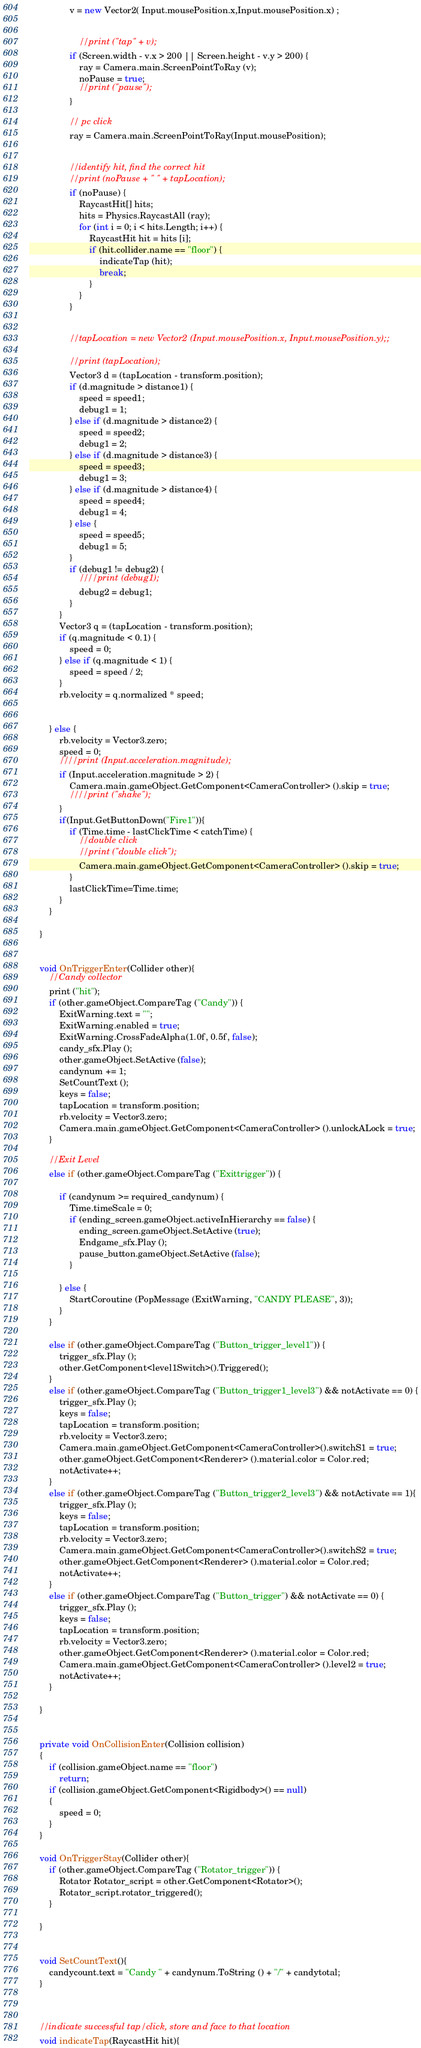<code> <loc_0><loc_0><loc_500><loc_500><_C#_>				v = new Vector2( Input.mousePosition.x,Input.mousePosition.x) ;


					//print ("tap" + v);
				if (Screen.width - v.x > 200 || Screen.height - v.y > 200) {
					ray = Camera.main.ScreenPointToRay (v);
					noPause = true;
					//print ("pause");
				}

				// pc click
				ray = Camera.main.ScreenPointToRay(Input.mousePosition);


				//identify hit, find the correct hit
				//print (noPause + " " + tapLocation);
				if (noPause) {
					RaycastHit[] hits;
					hits = Physics.RaycastAll (ray);
					for (int i = 0; i < hits.Length; i++) {
						RaycastHit hit = hits [i];
						if (hit.collider.name == "floor") {
							indicateTap (hit);
							break;
						}
					}
				}


				//tapLocation = new Vector2 (Input.mousePosition.x, Input.mousePosition.y);;

				//print (tapLocation);
				Vector3 d = (tapLocation - transform.position);
				if (d.magnitude > distance1) {
					speed = speed1;
					debug1 = 1;
				} else if (d.magnitude > distance2) {
					speed = speed2;
					debug1 = 2;
				} else if (d.magnitude > distance3) {
					speed = speed3;
					debug1 = 3;
				} else if (d.magnitude > distance4) {
					speed = speed4;
					debug1 = 4;
				} else {
					speed = speed5;
					debug1 = 5;
				}
				if (debug1 != debug2) {
					////print (debug1);
					debug2 = debug1;
				}
			}
			Vector3 q = (tapLocation - transform.position);
			if (q.magnitude < 0.1) {
				speed = 0;
			} else if (q.magnitude < 1) {
				speed = speed / 2;
			}
			rb.velocity = q.normalized * speed;


		} else {
			rb.velocity = Vector3.zero;
			speed = 0;
			////print (Input.acceleration.magnitude);
			if (Input.acceleration.magnitude > 2) {
				Camera.main.gameObject.GetComponent<CameraController> ().skip = true;
				////print ("shake");
			}	
			if(Input.GetButtonDown("Fire1")){
				if (Time.time - lastClickTime < catchTime) {
					//double click
					//print ("double click");
					Camera.main.gameObject.GetComponent<CameraController> ().skip = true;
				}
				lastClickTime=Time.time;
			}
		}

	}


	void OnTriggerEnter(Collider other){
		//Candy collector
		print ("hit");
		if (other.gameObject.CompareTag ("Candy")) {
			ExitWarning.text = "";
			ExitWarning.enabled = true;
			ExitWarning.CrossFadeAlpha(1.0f, 0.5f, false);
			candy_sfx.Play ();
			other.gameObject.SetActive (false);
			candynum += 1;
			SetCountText ();
			keys = false;
			tapLocation = transform.position;
			rb.velocity = Vector3.zero;
			Camera.main.gameObject.GetComponent<CameraController> ().unlockALock = true;
		}

		//Exit Level
		else if (other.gameObject.CompareTag ("Exittrigger")) {

			if (candynum >= required_candynum) {
				Time.timeScale = 0;
				if (ending_screen.gameObject.activeInHierarchy == false) {
					ending_screen.gameObject.SetActive (true);
					Endgame_sfx.Play ();
					pause_button.gameObject.SetActive (false);
				}

			} else {
				StartCoroutine (PopMessage (ExitWarning, "CANDY PLEASE", 3));
			}
		}

		else if (other.gameObject.CompareTag ("Button_trigger_level1")) {
			trigger_sfx.Play ();
			other.GetComponent<level1Switch>().Triggered();
		}
		else if (other.gameObject.CompareTag ("Button_trigger1_level3") && notActivate == 0) {
			trigger_sfx.Play ();
			keys = false;
			tapLocation = transform.position;
			rb.velocity = Vector3.zero;
			Camera.main.gameObject.GetComponent<CameraController>().switchS1 = true;
			other.gameObject.GetComponent<Renderer> ().material.color = Color.red;
			notActivate++;
		}
		else if (other.gameObject.CompareTag ("Button_trigger2_level3") && notActivate == 1){
			trigger_sfx.Play ();
			keys = false;
			tapLocation = transform.position;
			rb.velocity = Vector3.zero;
			Camera.main.gameObject.GetComponent<CameraController>().switchS2 = true;
			other.gameObject.GetComponent<Renderer> ().material.color = Color.red;
			notActivate++;
		}
		else if (other.gameObject.CompareTag ("Button_trigger") && notActivate == 0) {
			trigger_sfx.Play ();
			keys = false;
			tapLocation = transform.position;
			rb.velocity = Vector3.zero;
			other.gameObject.GetComponent<Renderer> ().material.color = Color.red;
			Camera.main.gameObject.GetComponent<CameraController> ().level2 = true;
			notActivate++;
		}

	}


    private void OnCollisionEnter(Collision collision)
    {
        if (collision.gameObject.name == "floor")
            return;
        if (collision.gameObject.GetComponent<Rigidbody>() == null)
        {
            speed = 0;
        }
    }

    void OnTriggerStay(Collider other){
		if (other.gameObject.CompareTag ("Rotator_trigger")) {
			Rotator Rotator_script = other.GetComponent<Rotator>();
			Rotator_script.rotator_triggered();
		}

	}


	void SetCountText(){
		candycount.text = "Candy " + candynum.ToString () + "/" + candytotal;
	}



	//indicate successful tap/click, store and face to that location
	void indicateTap(RaycastHit hit){</code> 